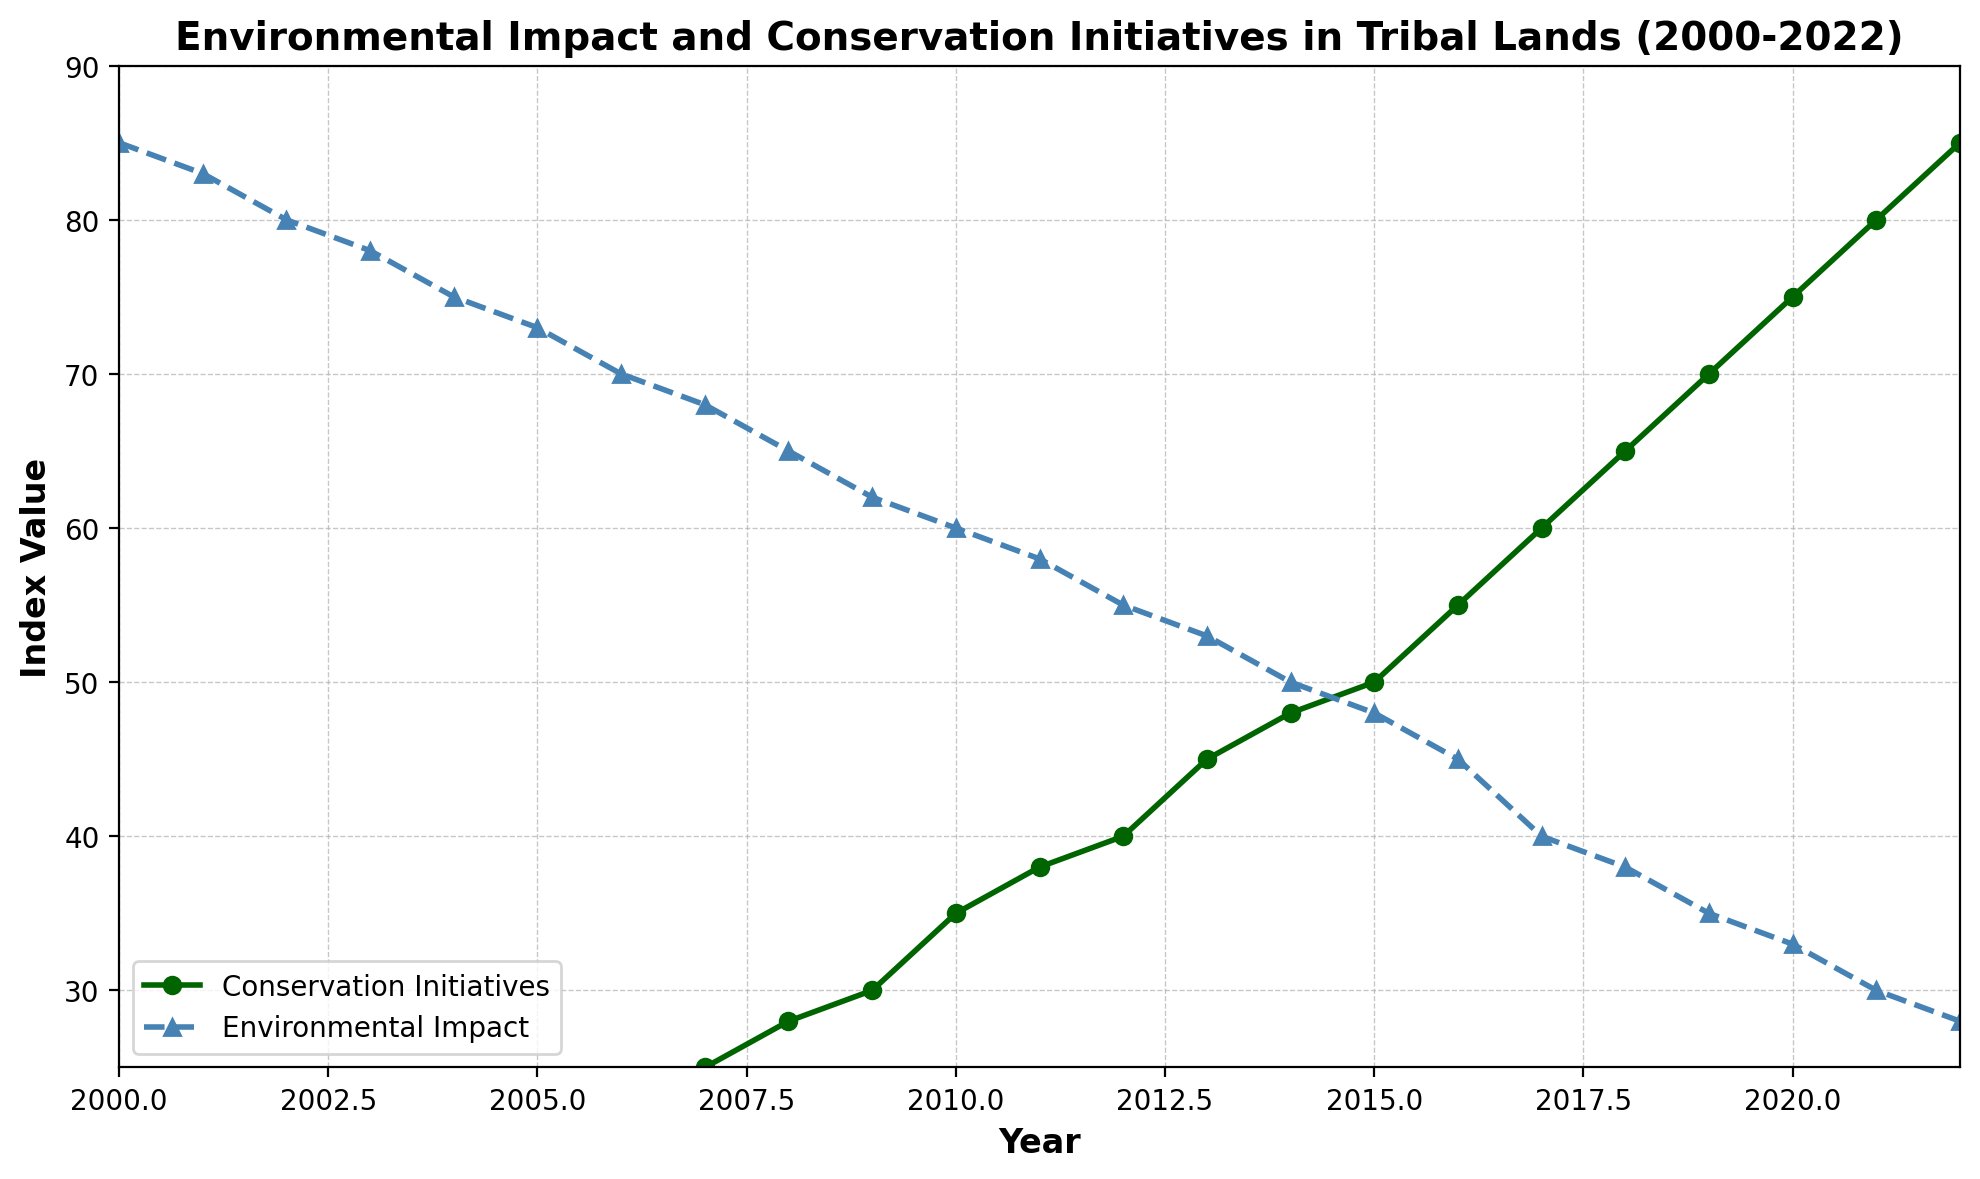What trend do you observe for Conservation Initiatives over time? Conservation Initiatives show a consistent increase over time from 10 in 2000 to 85 in 2022.
Answer: They consistently increase In which year did the Environmental Impact first drop below 50? Observing the Environmental Impact trend line, it drops below 50 between 2012 and 2013.
Answer: 2013 Compare the rate of change between Conservation Initiatives and Environmental Impact from 2000 to 2010. From 2000 to 2010, Conservation Initiatives increased from 10 to 35 (25 units), while Environmental Impact decreased from 85 to 60 (25 units). Both rates of change are equal but in opposite directions.
Answer: Both changed by 25 units What is the combined value of Conservation Initiatives and Environmental Impact in the year 2020? In 2020, the Conservation Initiatives are at 75, and Environmental Impact is at 33. Combining these gives 75 + 33 = 108.
Answer: 108 At what year do Conservation Initiatives reach 50 and what is the corresponding Environmental Impact value? Observing the trend lines, Conservation Initiatives reach 50 in 2015. At this point, the Environmental Impact value is 48.
Answer: 2015, 48 Which year shows the maximum gap between Conservation Initiatives and Environmental Impact? The gap between the two lines is visually most significant in the later years. By 2022, Conservation Initiatives are 85 and Environmental Impact is 28, making the gap 57.
Answer: 2022 What color is used to represent the trend of Environmental Impact in the plot? The Environmental Impact trend is represented by the color "steelblue" with triangle markers and a dashed line style.
Answer: Steelblue How many years did it take for the Conservation Initiatives to increase from 10 to 30? Conservation Initiatives start at 10 in the year 2000 and reach 30 in the year 2009. It took 9 years to increase from 10 to 30.
Answer: 9 years When do Conservation Initiatives surpass 60 and what is the value of Environmental Impact at that time? Conservation Initiatives surpass 60 in 2017. At this point, Environmental Impact is at 40.
Answer: 2017, 40 